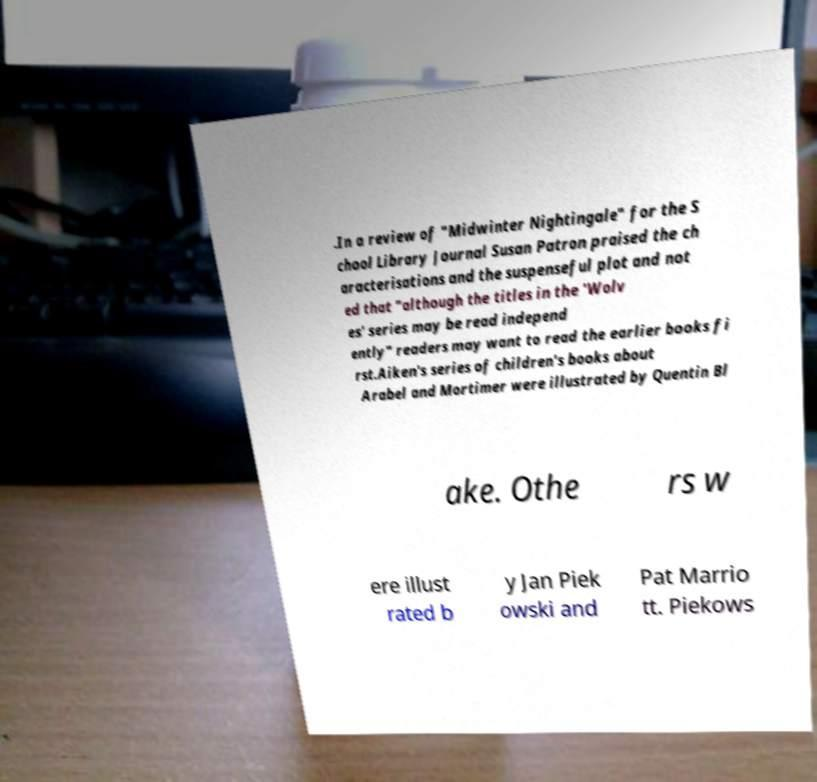I need the written content from this picture converted into text. Can you do that? .In a review of "Midwinter Nightingale" for the S chool Library Journal Susan Patron praised the ch aracterisations and the suspenseful plot and not ed that "although the titles in the 'Wolv es' series may be read independ ently" readers may want to read the earlier books fi rst.Aiken's series of children's books about Arabel and Mortimer were illustrated by Quentin Bl ake. Othe rs w ere illust rated b y Jan Piek owski and Pat Marrio tt. Piekows 